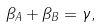Convert formula to latex. <formula><loc_0><loc_0><loc_500><loc_500>\beta _ { A } + \beta _ { B } = \gamma ,</formula> 